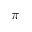Convert formula to latex. <formula><loc_0><loc_0><loc_500><loc_500>\pi</formula> 